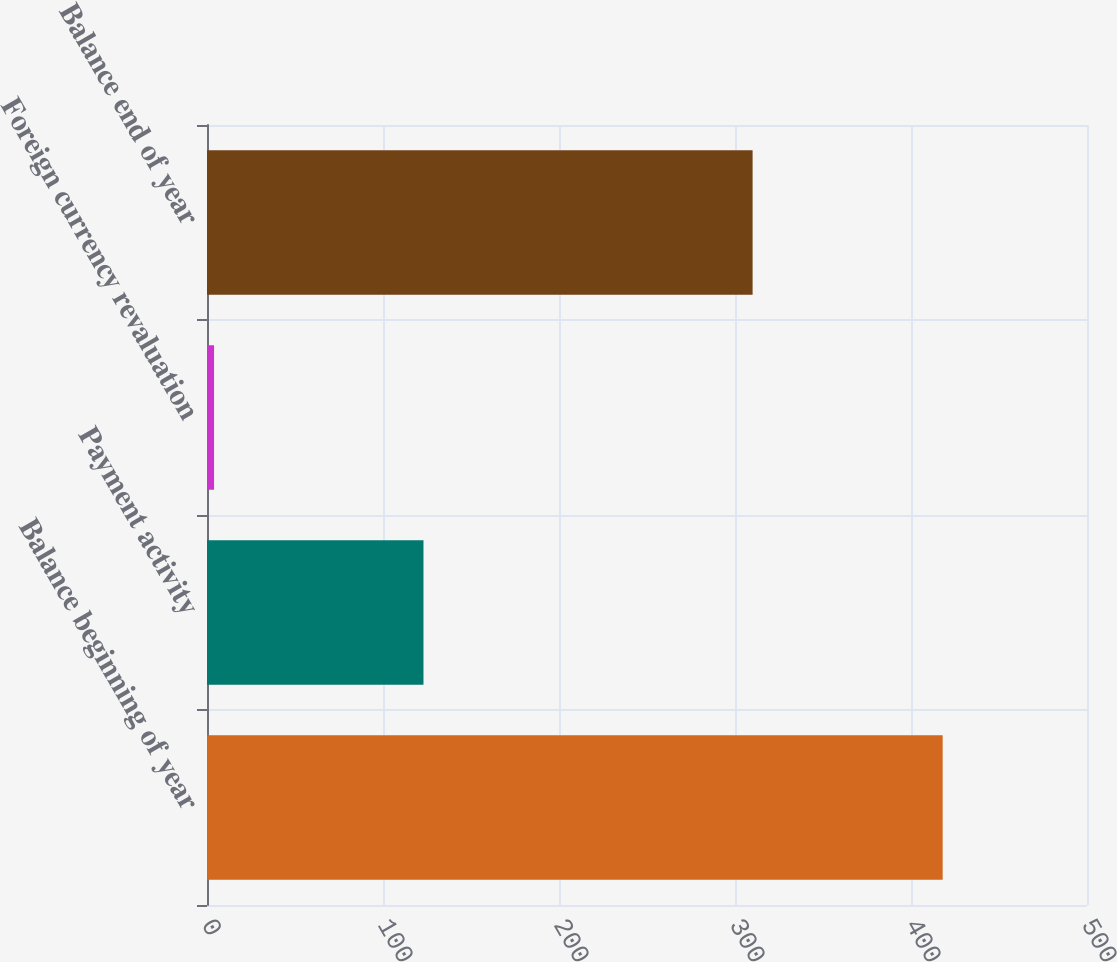Convert chart. <chart><loc_0><loc_0><loc_500><loc_500><bar_chart><fcel>Balance beginning of year<fcel>Payment activity<fcel>Foreign currency revaluation<fcel>Balance end of year<nl><fcel>418<fcel>123<fcel>4<fcel>310<nl></chart> 